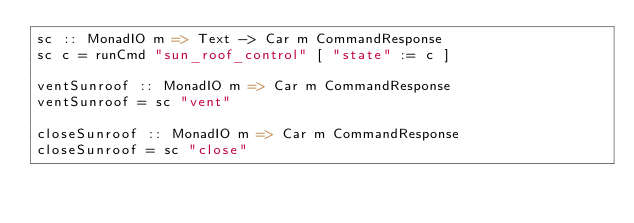Convert code to text. <code><loc_0><loc_0><loc_500><loc_500><_Haskell_>sc :: MonadIO m => Text -> Car m CommandResponse
sc c = runCmd "sun_roof_control" [ "state" := c ]

ventSunroof :: MonadIO m => Car m CommandResponse
ventSunroof = sc "vent"

closeSunroof :: MonadIO m => Car m CommandResponse
closeSunroof = sc "close"
</code> 